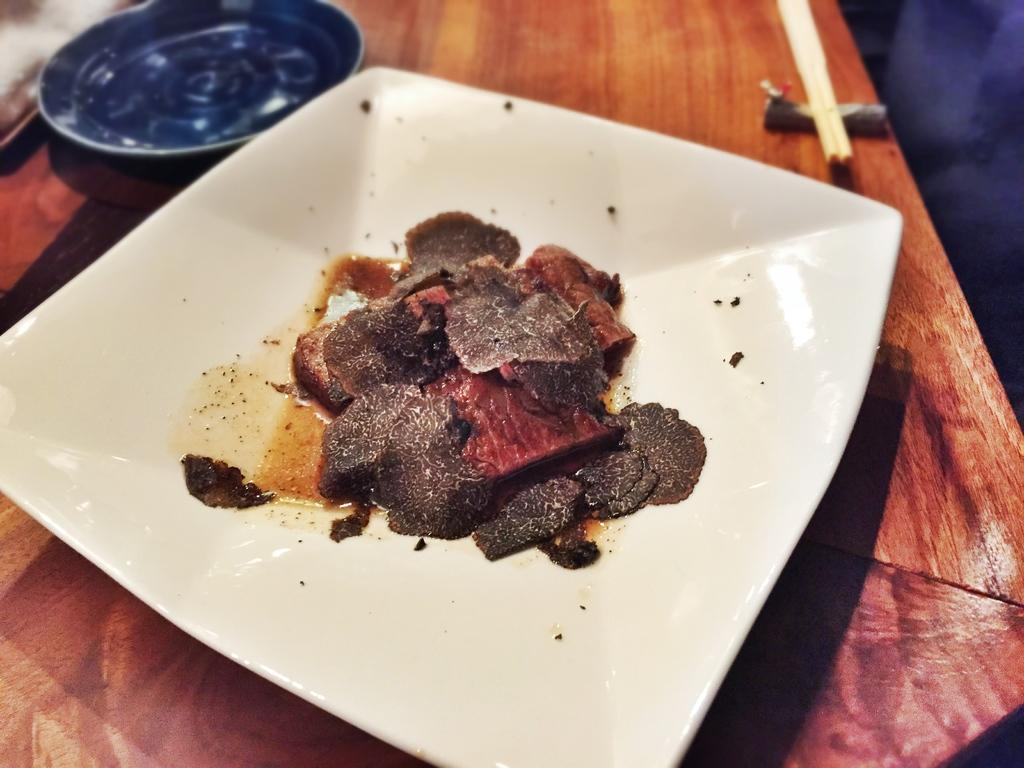What is on the plate that is visible in the image? There are food items on a plate in the image. Where is the plate located in the image? The plate is placed on a table in the image. What utensil is visible in the image? Chopsticks are visible in the image. Are there any other plates in the image? Yes, there is another plate in the image. What time of day is it in the image, considering the presence of night? The image does not depict a night scene, as there is no mention of night or any related elements in the provided facts. 